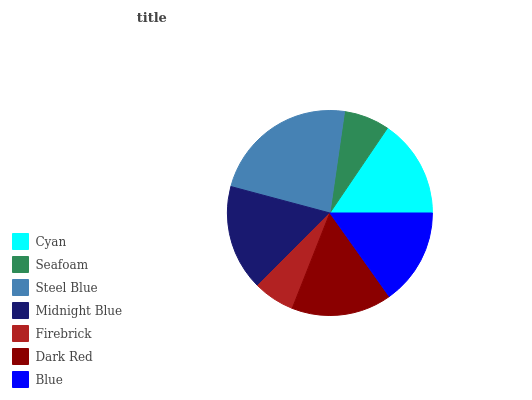Is Firebrick the minimum?
Answer yes or no. Yes. Is Steel Blue the maximum?
Answer yes or no. Yes. Is Seafoam the minimum?
Answer yes or no. No. Is Seafoam the maximum?
Answer yes or no. No. Is Cyan greater than Seafoam?
Answer yes or no. Yes. Is Seafoam less than Cyan?
Answer yes or no. Yes. Is Seafoam greater than Cyan?
Answer yes or no. No. Is Cyan less than Seafoam?
Answer yes or no. No. Is Cyan the high median?
Answer yes or no. Yes. Is Cyan the low median?
Answer yes or no. Yes. Is Dark Red the high median?
Answer yes or no. No. Is Firebrick the low median?
Answer yes or no. No. 